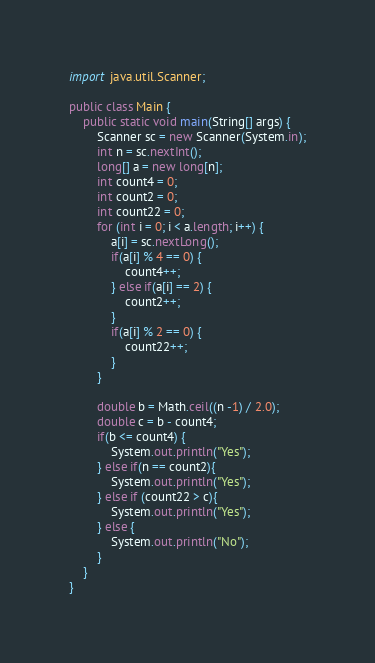Convert code to text. <code><loc_0><loc_0><loc_500><loc_500><_Java_>import java.util.Scanner;

public class Main {
    public static void main(String[] args) {
        Scanner sc = new Scanner(System.in);
        int n = sc.nextInt();
        long[] a = new long[n];
        int count4 = 0;
        int count2 = 0;
        int count22 = 0;
        for (int i = 0; i < a.length; i++) {
            a[i] = sc.nextLong();
            if(a[i] % 4 == 0) {
                count4++;
            } else if(a[i] == 2) {
                count2++;
            }
            if(a[i] % 2 == 0) {
                count22++;
            }
        }

        double b = Math.ceil((n -1) / 2.0);
        double c = b - count4;
        if(b <= count4) {
            System.out.println("Yes");
        } else if(n == count2){
            System.out.println("Yes");
        } else if (count22 > c){
            System.out.println("Yes");
        } else {
            System.out.println("No");
        }
    }
}</code> 